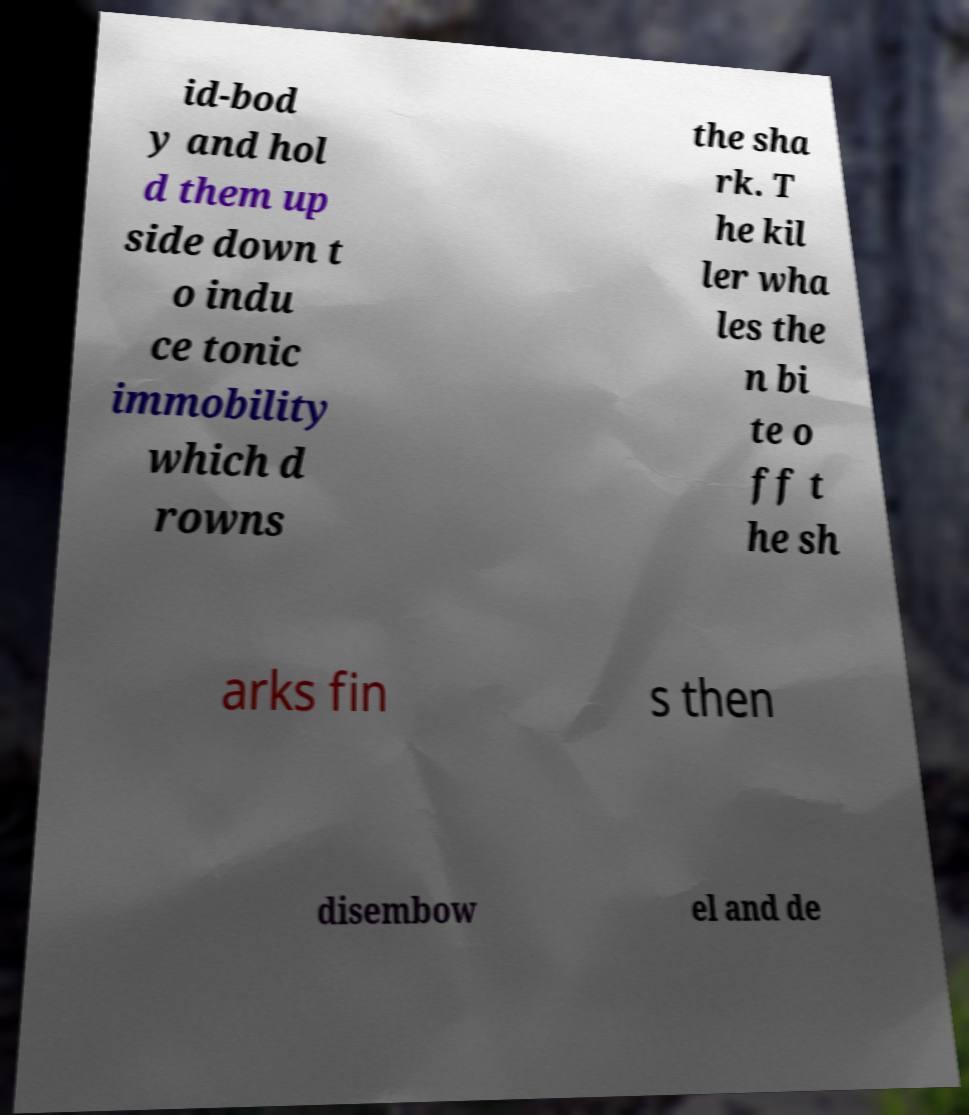I need the written content from this picture converted into text. Can you do that? id-bod y and hol d them up side down t o indu ce tonic immobility which d rowns the sha rk. T he kil ler wha les the n bi te o ff t he sh arks fin s then disembow el and de 